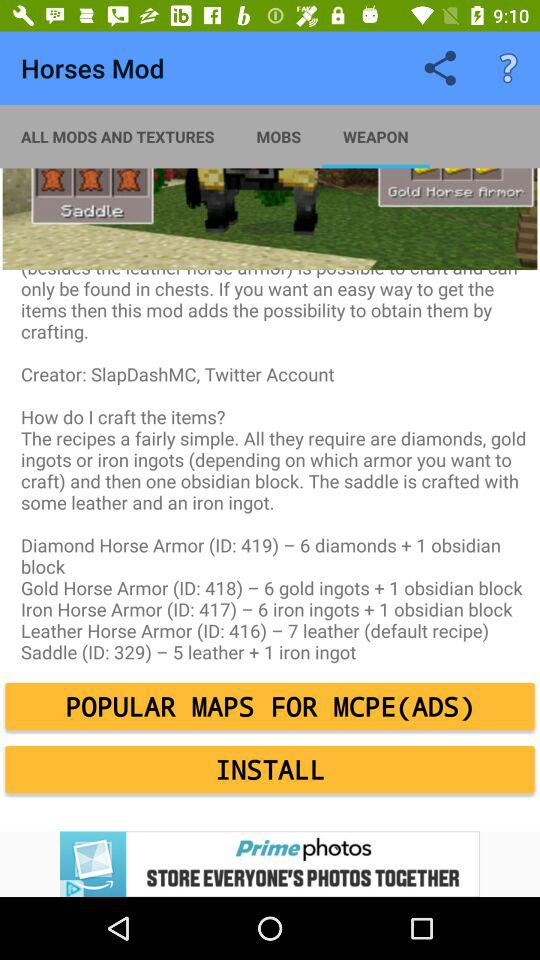How many more leather is required to craft a saddle than a leather horse armor?
Answer the question using a single word or phrase. 2 